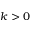<formula> <loc_0><loc_0><loc_500><loc_500>k > 0</formula> 